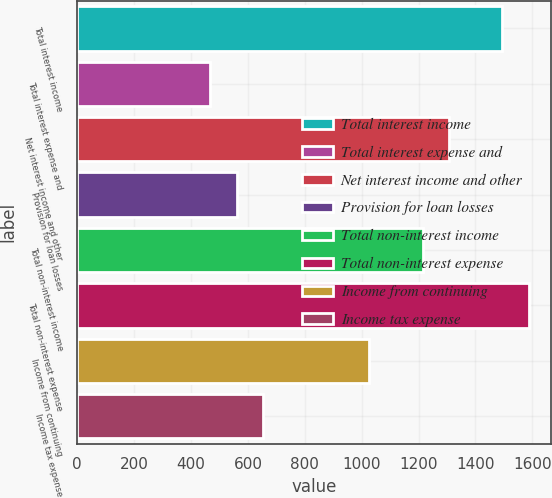Convert chart. <chart><loc_0><loc_0><loc_500><loc_500><bar_chart><fcel>Total interest income<fcel>Total interest expense and<fcel>Net interest income and other<fcel>Provision for loan losses<fcel>Total non-interest income<fcel>Total non-interest expense<fcel>Income from continuing<fcel>Income tax expense<nl><fcel>1494.3<fcel>467.01<fcel>1307.52<fcel>560.4<fcel>1214.13<fcel>1587.69<fcel>1027.35<fcel>653.79<nl></chart> 